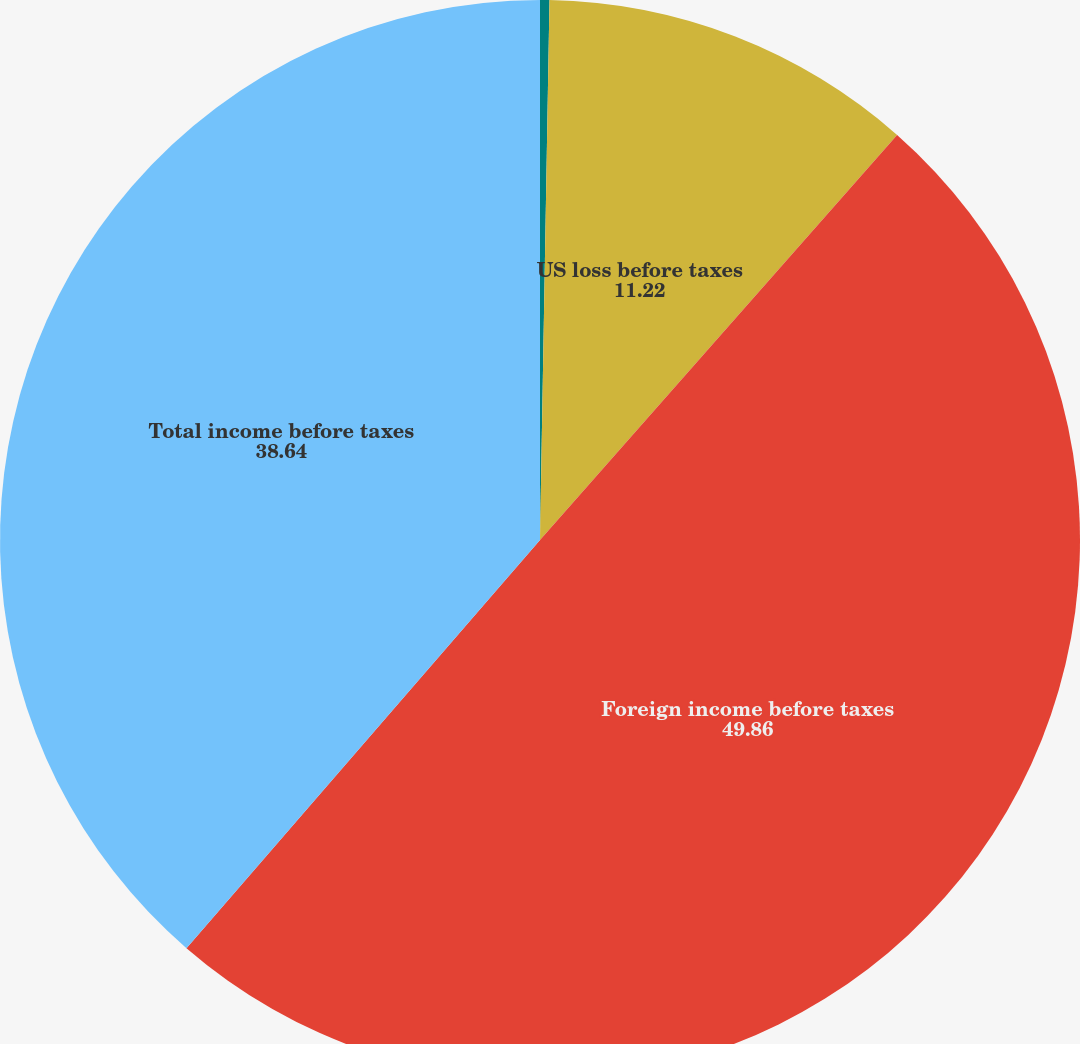Convert chart. <chart><loc_0><loc_0><loc_500><loc_500><pie_chart><fcel>(DOLLARS IN THOUSANDS)<fcel>US loss before taxes<fcel>Foreign income before taxes<fcel>Total income before taxes<nl><fcel>0.28%<fcel>11.22%<fcel>49.86%<fcel>38.64%<nl></chart> 